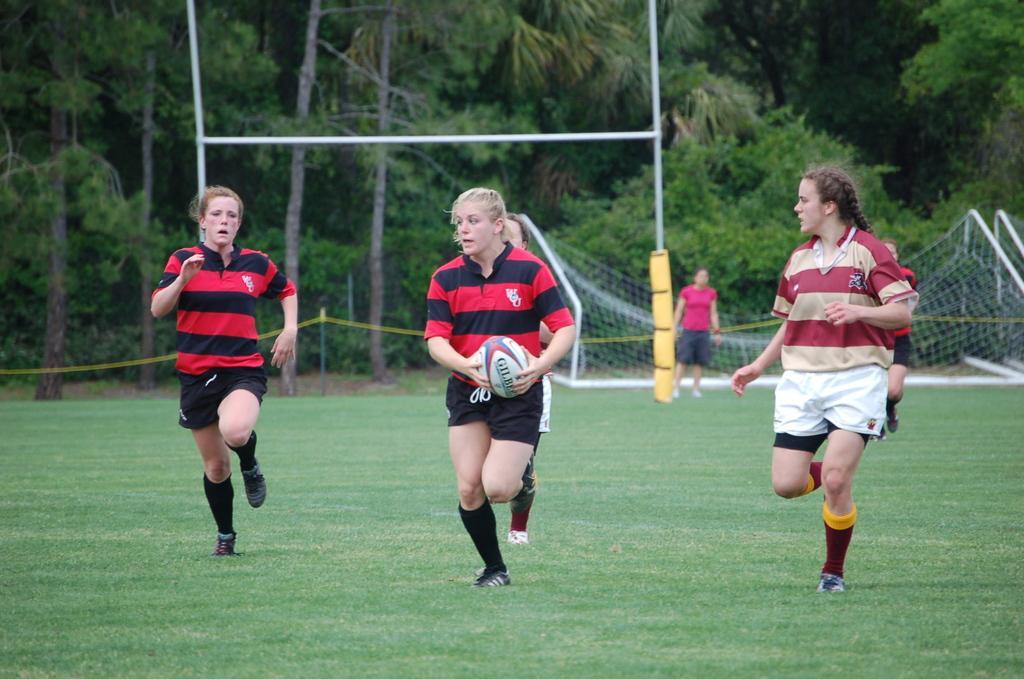Can you describe this image briefly? In this image we can see some women running and playing on the ground. There is one football net on the ground, one woman standing near the football net, one yellow object with white poles on the ground, one rope pole barrier in the background, one woman holding a ball in the middle of the image, some trees in the background and some grass on the ground. 